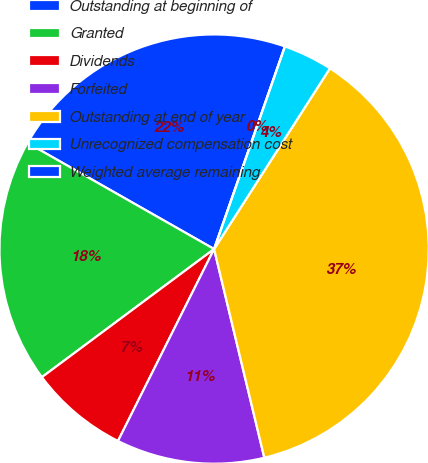Convert chart to OTSL. <chart><loc_0><loc_0><loc_500><loc_500><pie_chart><fcel>Outstanding at beginning of<fcel>Granted<fcel>Dividends<fcel>Forfeited<fcel>Outstanding at end of year<fcel>Unrecognized compensation cost<fcel>Weighted average remaining<nl><fcel>22.12%<fcel>18.41%<fcel>7.43%<fcel>11.15%<fcel>37.17%<fcel>3.72%<fcel>0.0%<nl></chart> 